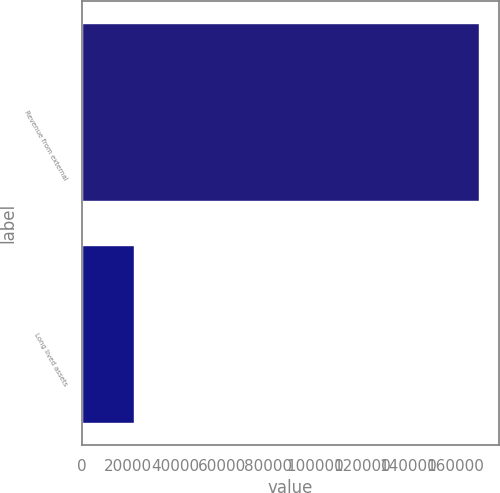Convert chart. <chart><loc_0><loc_0><loc_500><loc_500><bar_chart><fcel>Revenue from external<fcel>Long lived assets<nl><fcel>170010<fcel>22347<nl></chart> 